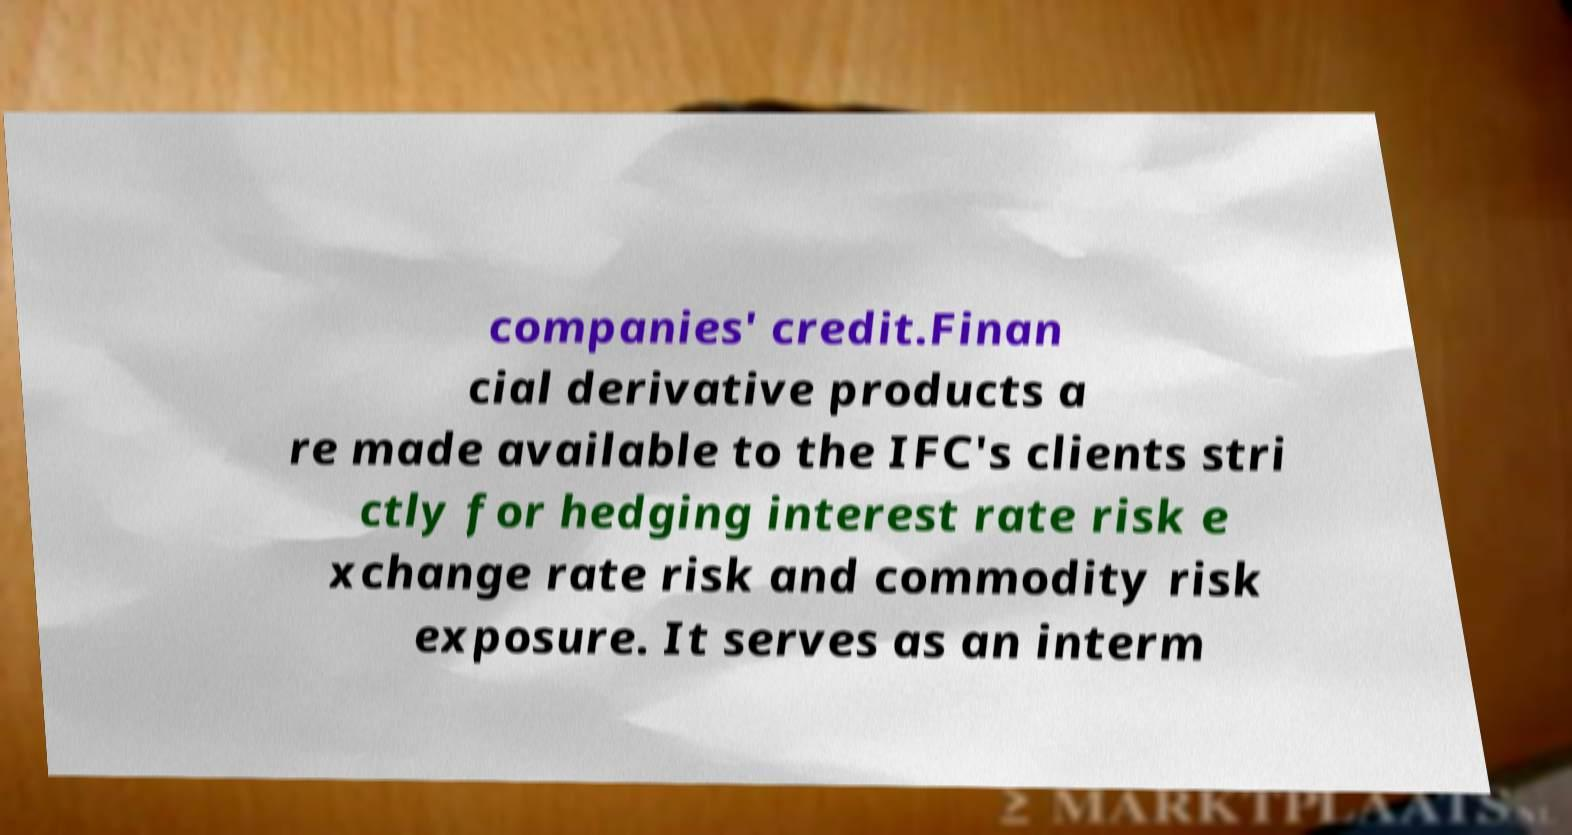I need the written content from this picture converted into text. Can you do that? companies' credit.Finan cial derivative products a re made available to the IFC's clients stri ctly for hedging interest rate risk e xchange rate risk and commodity risk exposure. It serves as an interm 